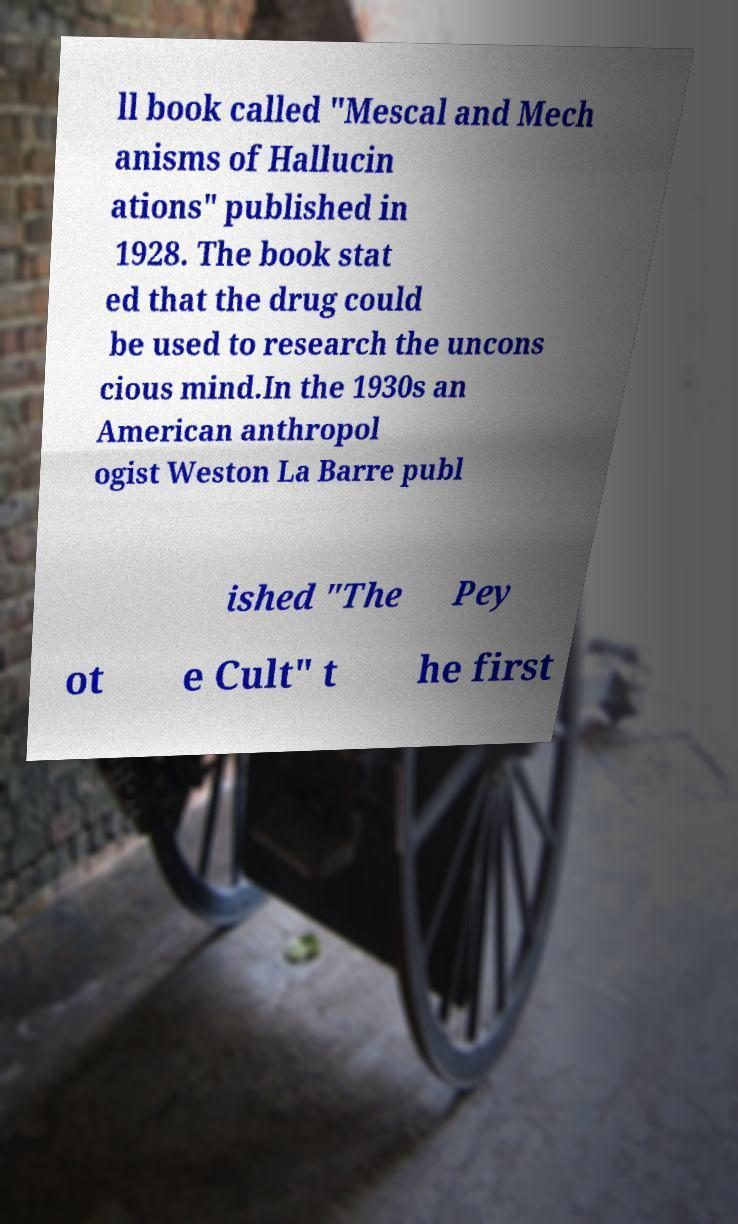Please identify and transcribe the text found in this image. ll book called "Mescal and Mech anisms of Hallucin ations" published in 1928. The book stat ed that the drug could be used to research the uncons cious mind.In the 1930s an American anthropol ogist Weston La Barre publ ished "The Pey ot e Cult" t he first 